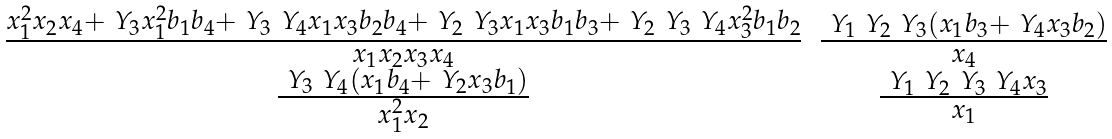<formula> <loc_0><loc_0><loc_500><loc_500>\begin{matrix} \frac { x _ { 1 } ^ { 2 } x _ { 2 } x _ { 4 } + \ Y _ { 3 } x _ { 1 } ^ { 2 } b _ { 1 } b _ { 4 } + \ Y _ { 3 } \ Y _ { 4 } x _ { 1 } x _ { 3 } b _ { 2 } b _ { 4 } + \ Y _ { 2 } \ Y _ { 3 } x _ { 1 } x _ { 3 } b _ { 1 } b _ { 3 } + \ Y _ { 2 } \ Y _ { 3 } \ Y _ { 4 } x _ { 3 } ^ { 2 } b _ { 1 } b _ { 2 } } { x _ { 1 } x _ { 2 } x _ { 3 } x _ { 4 } } & \frac { \ Y _ { 1 } \ Y _ { 2 } \ Y _ { 3 } ( x _ { 1 } b _ { 3 } + \ Y _ { 4 } x _ { 3 } b _ { 2 } ) } { x _ { 4 } } \\ \frac { \ Y _ { 3 } \ Y _ { 4 } ( x _ { 1 } b _ { 4 } + \ Y _ { 2 } x _ { 3 } b _ { 1 } ) } { x _ { 1 } ^ { 2 } x _ { 2 } } & \frac { \ Y _ { 1 } \ Y _ { 2 } \ Y _ { 3 } \ Y _ { 4 } x _ { 3 } } { x _ { 1 } } \end{matrix}</formula> 